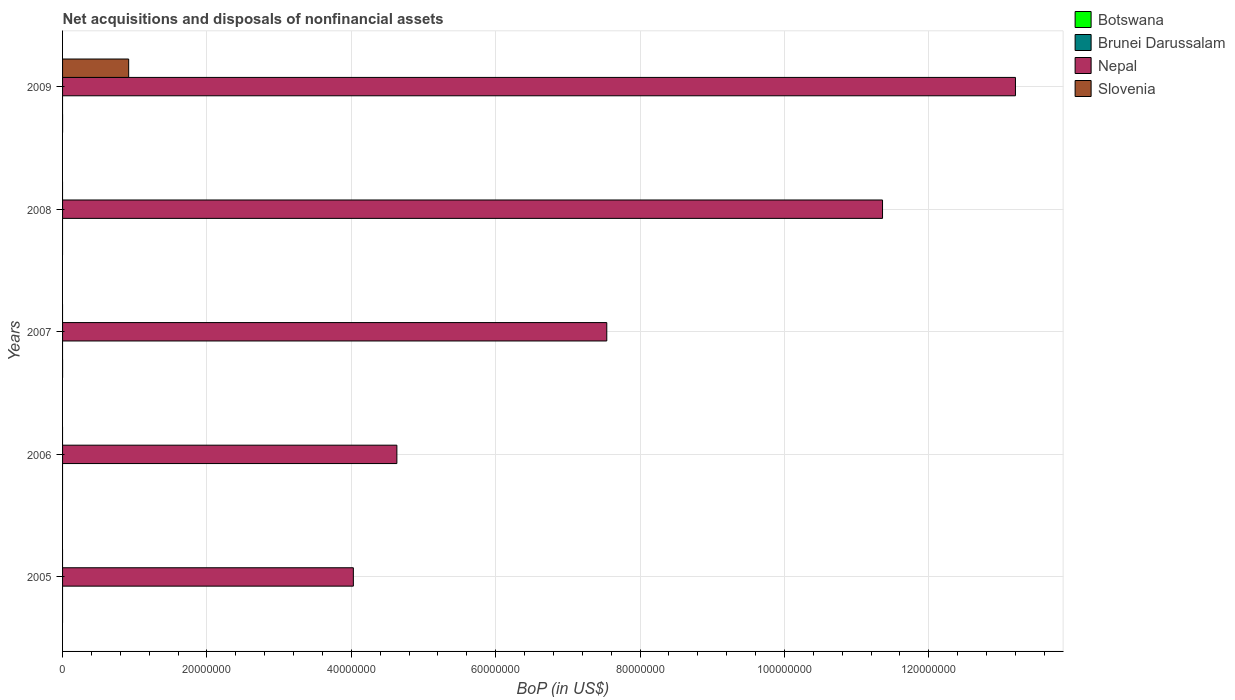How many different coloured bars are there?
Your answer should be very brief. 2. Are the number of bars per tick equal to the number of legend labels?
Give a very brief answer. No. Are the number of bars on each tick of the Y-axis equal?
Ensure brevity in your answer.  No. How many bars are there on the 3rd tick from the top?
Your answer should be compact. 1. How many bars are there on the 1st tick from the bottom?
Provide a short and direct response. 1. In how many cases, is the number of bars for a given year not equal to the number of legend labels?
Ensure brevity in your answer.  5. What is the Balance of Payments in Nepal in 2009?
Offer a very short reply. 1.32e+08. Across all years, what is the maximum Balance of Payments in Nepal?
Make the answer very short. 1.32e+08. Across all years, what is the minimum Balance of Payments in Botswana?
Provide a short and direct response. 0. In which year was the Balance of Payments in Nepal maximum?
Offer a terse response. 2009. What is the total Balance of Payments in Nepal in the graph?
Make the answer very short. 4.08e+08. What is the difference between the Balance of Payments in Nepal in 2005 and the Balance of Payments in Botswana in 2007?
Offer a very short reply. 4.03e+07. What is the average Balance of Payments in Botswana per year?
Keep it short and to the point. 0. In the year 2009, what is the difference between the Balance of Payments in Slovenia and Balance of Payments in Nepal?
Your response must be concise. -1.23e+08. In how many years, is the Balance of Payments in Nepal greater than 12000000 US$?
Your response must be concise. 5. What is the ratio of the Balance of Payments in Nepal in 2006 to that in 2008?
Give a very brief answer. 0.41. What is the difference between the highest and the second highest Balance of Payments in Nepal?
Offer a very short reply. 1.84e+07. What is the difference between the highest and the lowest Balance of Payments in Slovenia?
Provide a succinct answer. 9.16e+06. Is the sum of the Balance of Payments in Nepal in 2005 and 2007 greater than the maximum Balance of Payments in Slovenia across all years?
Ensure brevity in your answer.  Yes. Is it the case that in every year, the sum of the Balance of Payments in Slovenia and Balance of Payments in Botswana is greater than the sum of Balance of Payments in Nepal and Balance of Payments in Brunei Darussalam?
Your answer should be very brief. No. Is it the case that in every year, the sum of the Balance of Payments in Nepal and Balance of Payments in Slovenia is greater than the Balance of Payments in Botswana?
Your answer should be very brief. Yes. How many bars are there?
Offer a very short reply. 6. Are all the bars in the graph horizontal?
Provide a succinct answer. Yes. How many years are there in the graph?
Ensure brevity in your answer.  5. What is the difference between two consecutive major ticks on the X-axis?
Make the answer very short. 2.00e+07. Where does the legend appear in the graph?
Make the answer very short. Top right. What is the title of the graph?
Provide a succinct answer. Net acquisitions and disposals of nonfinancial assets. What is the label or title of the X-axis?
Offer a very short reply. BoP (in US$). What is the BoP (in US$) of Nepal in 2005?
Ensure brevity in your answer.  4.03e+07. What is the BoP (in US$) of Slovenia in 2005?
Keep it short and to the point. 0. What is the BoP (in US$) in Botswana in 2006?
Ensure brevity in your answer.  0. What is the BoP (in US$) of Nepal in 2006?
Make the answer very short. 4.63e+07. What is the BoP (in US$) of Slovenia in 2006?
Give a very brief answer. 0. What is the BoP (in US$) in Botswana in 2007?
Offer a very short reply. 0. What is the BoP (in US$) of Nepal in 2007?
Give a very brief answer. 7.54e+07. What is the BoP (in US$) of Slovenia in 2007?
Offer a very short reply. 0. What is the BoP (in US$) in Nepal in 2008?
Give a very brief answer. 1.14e+08. What is the BoP (in US$) in Botswana in 2009?
Provide a succinct answer. 0. What is the BoP (in US$) in Brunei Darussalam in 2009?
Provide a succinct answer. 0. What is the BoP (in US$) in Nepal in 2009?
Keep it short and to the point. 1.32e+08. What is the BoP (in US$) in Slovenia in 2009?
Your answer should be compact. 9.16e+06. Across all years, what is the maximum BoP (in US$) in Nepal?
Offer a terse response. 1.32e+08. Across all years, what is the maximum BoP (in US$) in Slovenia?
Keep it short and to the point. 9.16e+06. Across all years, what is the minimum BoP (in US$) of Nepal?
Ensure brevity in your answer.  4.03e+07. Across all years, what is the minimum BoP (in US$) of Slovenia?
Offer a terse response. 0. What is the total BoP (in US$) of Botswana in the graph?
Your answer should be compact. 0. What is the total BoP (in US$) of Brunei Darussalam in the graph?
Keep it short and to the point. 0. What is the total BoP (in US$) in Nepal in the graph?
Give a very brief answer. 4.08e+08. What is the total BoP (in US$) of Slovenia in the graph?
Provide a short and direct response. 9.16e+06. What is the difference between the BoP (in US$) in Nepal in 2005 and that in 2006?
Offer a terse response. -6.03e+06. What is the difference between the BoP (in US$) in Nepal in 2005 and that in 2007?
Provide a succinct answer. -3.51e+07. What is the difference between the BoP (in US$) of Nepal in 2005 and that in 2008?
Offer a very short reply. -7.33e+07. What is the difference between the BoP (in US$) in Nepal in 2005 and that in 2009?
Offer a very short reply. -9.17e+07. What is the difference between the BoP (in US$) in Nepal in 2006 and that in 2007?
Keep it short and to the point. -2.91e+07. What is the difference between the BoP (in US$) in Nepal in 2006 and that in 2008?
Offer a very short reply. -6.73e+07. What is the difference between the BoP (in US$) of Nepal in 2006 and that in 2009?
Offer a very short reply. -8.57e+07. What is the difference between the BoP (in US$) in Nepal in 2007 and that in 2008?
Offer a very short reply. -3.82e+07. What is the difference between the BoP (in US$) of Nepal in 2007 and that in 2009?
Provide a succinct answer. -5.66e+07. What is the difference between the BoP (in US$) in Nepal in 2008 and that in 2009?
Give a very brief answer. -1.84e+07. What is the difference between the BoP (in US$) of Nepal in 2005 and the BoP (in US$) of Slovenia in 2009?
Provide a short and direct response. 3.11e+07. What is the difference between the BoP (in US$) in Nepal in 2006 and the BoP (in US$) in Slovenia in 2009?
Make the answer very short. 3.72e+07. What is the difference between the BoP (in US$) in Nepal in 2007 and the BoP (in US$) in Slovenia in 2009?
Make the answer very short. 6.62e+07. What is the difference between the BoP (in US$) of Nepal in 2008 and the BoP (in US$) of Slovenia in 2009?
Ensure brevity in your answer.  1.04e+08. What is the average BoP (in US$) of Botswana per year?
Offer a very short reply. 0. What is the average BoP (in US$) in Nepal per year?
Provide a succinct answer. 8.15e+07. What is the average BoP (in US$) of Slovenia per year?
Give a very brief answer. 1.83e+06. In the year 2009, what is the difference between the BoP (in US$) in Nepal and BoP (in US$) in Slovenia?
Your answer should be compact. 1.23e+08. What is the ratio of the BoP (in US$) in Nepal in 2005 to that in 2006?
Offer a terse response. 0.87. What is the ratio of the BoP (in US$) of Nepal in 2005 to that in 2007?
Keep it short and to the point. 0.53. What is the ratio of the BoP (in US$) in Nepal in 2005 to that in 2008?
Your answer should be compact. 0.35. What is the ratio of the BoP (in US$) of Nepal in 2005 to that in 2009?
Keep it short and to the point. 0.31. What is the ratio of the BoP (in US$) of Nepal in 2006 to that in 2007?
Keep it short and to the point. 0.61. What is the ratio of the BoP (in US$) of Nepal in 2006 to that in 2008?
Give a very brief answer. 0.41. What is the ratio of the BoP (in US$) of Nepal in 2006 to that in 2009?
Provide a succinct answer. 0.35. What is the ratio of the BoP (in US$) in Nepal in 2007 to that in 2008?
Keep it short and to the point. 0.66. What is the ratio of the BoP (in US$) in Nepal in 2007 to that in 2009?
Make the answer very short. 0.57. What is the ratio of the BoP (in US$) in Nepal in 2008 to that in 2009?
Offer a terse response. 0.86. What is the difference between the highest and the second highest BoP (in US$) in Nepal?
Offer a very short reply. 1.84e+07. What is the difference between the highest and the lowest BoP (in US$) of Nepal?
Your response must be concise. 9.17e+07. What is the difference between the highest and the lowest BoP (in US$) of Slovenia?
Offer a terse response. 9.16e+06. 